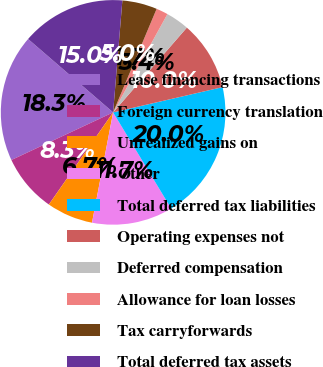Convert chart. <chart><loc_0><loc_0><loc_500><loc_500><pie_chart><fcel>Lease financing transactions<fcel>Foreign currency translation<fcel>Unrealized gains on<fcel>Other<fcel>Total deferred tax liabilities<fcel>Operating expenses not<fcel>Deferred compensation<fcel>Allowance for loan losses<fcel>Tax carryforwards<fcel>Total deferred tax assets<nl><fcel>18.3%<fcel>8.34%<fcel>6.68%<fcel>11.66%<fcel>19.96%<fcel>10.0%<fcel>3.36%<fcel>1.7%<fcel>5.02%<fcel>14.98%<nl></chart> 